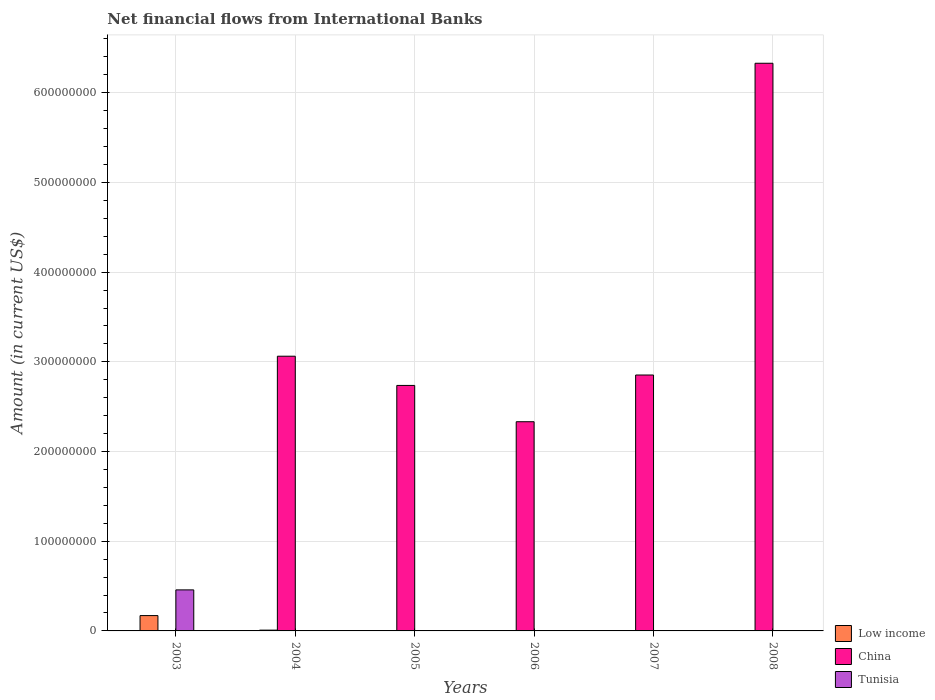How many different coloured bars are there?
Your answer should be very brief. 3. Are the number of bars on each tick of the X-axis equal?
Give a very brief answer. No. What is the net financial aid flows in China in 2006?
Keep it short and to the point. 2.33e+08. Across all years, what is the maximum net financial aid flows in China?
Offer a very short reply. 6.33e+08. In which year was the net financial aid flows in Low income maximum?
Keep it short and to the point. 2003. What is the total net financial aid flows in Low income in the graph?
Your answer should be compact. 1.80e+07. What is the difference between the net financial aid flows in China in 2007 and that in 2008?
Give a very brief answer. -3.48e+08. What is the difference between the net financial aid flows in Low income in 2007 and the net financial aid flows in Tunisia in 2003?
Give a very brief answer. -4.58e+07. What is the average net financial aid flows in Low income per year?
Give a very brief answer. 3.00e+06. In the year 2004, what is the difference between the net financial aid flows in China and net financial aid flows in Low income?
Provide a short and direct response. 3.05e+08. In how many years, is the net financial aid flows in China greater than 520000000 US$?
Keep it short and to the point. 1. What is the ratio of the net financial aid flows in China in 2005 to that in 2006?
Make the answer very short. 1.17. What is the difference between the highest and the second highest net financial aid flows in China?
Provide a short and direct response. 3.27e+08. What is the difference between the highest and the lowest net financial aid flows in Tunisia?
Offer a very short reply. 4.58e+07. Are all the bars in the graph horizontal?
Your response must be concise. No. How many years are there in the graph?
Your answer should be very brief. 6. What is the difference between two consecutive major ticks on the Y-axis?
Your answer should be compact. 1.00e+08. Does the graph contain any zero values?
Your response must be concise. Yes. How many legend labels are there?
Provide a short and direct response. 3. What is the title of the graph?
Your answer should be compact. Net financial flows from International Banks. What is the Amount (in current US$) in Low income in 2003?
Provide a succinct answer. 1.71e+07. What is the Amount (in current US$) of China in 2003?
Your answer should be very brief. 0. What is the Amount (in current US$) in Tunisia in 2003?
Provide a short and direct response. 4.58e+07. What is the Amount (in current US$) of Low income in 2004?
Ensure brevity in your answer.  8.75e+05. What is the Amount (in current US$) of China in 2004?
Keep it short and to the point. 3.06e+08. What is the Amount (in current US$) in Tunisia in 2004?
Ensure brevity in your answer.  0. What is the Amount (in current US$) in Low income in 2005?
Keep it short and to the point. 0. What is the Amount (in current US$) in China in 2005?
Keep it short and to the point. 2.74e+08. What is the Amount (in current US$) in China in 2006?
Ensure brevity in your answer.  2.33e+08. What is the Amount (in current US$) of Tunisia in 2006?
Keep it short and to the point. 0. What is the Amount (in current US$) in Low income in 2007?
Provide a short and direct response. 0. What is the Amount (in current US$) of China in 2007?
Your answer should be very brief. 2.85e+08. What is the Amount (in current US$) of Tunisia in 2007?
Provide a short and direct response. 0. What is the Amount (in current US$) of China in 2008?
Your answer should be very brief. 6.33e+08. Across all years, what is the maximum Amount (in current US$) in Low income?
Your answer should be very brief. 1.71e+07. Across all years, what is the maximum Amount (in current US$) of China?
Your answer should be compact. 6.33e+08. Across all years, what is the maximum Amount (in current US$) in Tunisia?
Ensure brevity in your answer.  4.58e+07. Across all years, what is the minimum Amount (in current US$) in Tunisia?
Make the answer very short. 0. What is the total Amount (in current US$) in Low income in the graph?
Offer a very short reply. 1.80e+07. What is the total Amount (in current US$) of China in the graph?
Ensure brevity in your answer.  1.73e+09. What is the total Amount (in current US$) in Tunisia in the graph?
Make the answer very short. 4.58e+07. What is the difference between the Amount (in current US$) of Low income in 2003 and that in 2004?
Offer a very short reply. 1.62e+07. What is the difference between the Amount (in current US$) of China in 2004 and that in 2005?
Make the answer very short. 3.26e+07. What is the difference between the Amount (in current US$) in China in 2004 and that in 2006?
Your answer should be very brief. 7.30e+07. What is the difference between the Amount (in current US$) of China in 2004 and that in 2007?
Ensure brevity in your answer.  2.10e+07. What is the difference between the Amount (in current US$) in China in 2004 and that in 2008?
Provide a succinct answer. -3.27e+08. What is the difference between the Amount (in current US$) of China in 2005 and that in 2006?
Make the answer very short. 4.05e+07. What is the difference between the Amount (in current US$) of China in 2005 and that in 2007?
Keep it short and to the point. -1.16e+07. What is the difference between the Amount (in current US$) of China in 2005 and that in 2008?
Provide a succinct answer. -3.59e+08. What is the difference between the Amount (in current US$) of China in 2006 and that in 2007?
Offer a very short reply. -5.21e+07. What is the difference between the Amount (in current US$) of China in 2006 and that in 2008?
Offer a terse response. -4.00e+08. What is the difference between the Amount (in current US$) in China in 2007 and that in 2008?
Ensure brevity in your answer.  -3.48e+08. What is the difference between the Amount (in current US$) of Low income in 2003 and the Amount (in current US$) of China in 2004?
Offer a terse response. -2.89e+08. What is the difference between the Amount (in current US$) in Low income in 2003 and the Amount (in current US$) in China in 2005?
Your response must be concise. -2.57e+08. What is the difference between the Amount (in current US$) in Low income in 2003 and the Amount (in current US$) in China in 2006?
Provide a succinct answer. -2.16e+08. What is the difference between the Amount (in current US$) in Low income in 2003 and the Amount (in current US$) in China in 2007?
Provide a succinct answer. -2.68e+08. What is the difference between the Amount (in current US$) in Low income in 2003 and the Amount (in current US$) in China in 2008?
Make the answer very short. -6.16e+08. What is the difference between the Amount (in current US$) of Low income in 2004 and the Amount (in current US$) of China in 2005?
Give a very brief answer. -2.73e+08. What is the difference between the Amount (in current US$) of Low income in 2004 and the Amount (in current US$) of China in 2006?
Your response must be concise. -2.32e+08. What is the difference between the Amount (in current US$) in Low income in 2004 and the Amount (in current US$) in China in 2007?
Your response must be concise. -2.84e+08. What is the difference between the Amount (in current US$) in Low income in 2004 and the Amount (in current US$) in China in 2008?
Provide a short and direct response. -6.32e+08. What is the average Amount (in current US$) in Low income per year?
Offer a terse response. 3.00e+06. What is the average Amount (in current US$) in China per year?
Offer a terse response. 2.89e+08. What is the average Amount (in current US$) of Tunisia per year?
Provide a succinct answer. 7.63e+06. In the year 2003, what is the difference between the Amount (in current US$) of Low income and Amount (in current US$) of Tunisia?
Provide a short and direct response. -2.86e+07. In the year 2004, what is the difference between the Amount (in current US$) in Low income and Amount (in current US$) in China?
Provide a succinct answer. -3.05e+08. What is the ratio of the Amount (in current US$) in Low income in 2003 to that in 2004?
Keep it short and to the point. 19.55. What is the ratio of the Amount (in current US$) of China in 2004 to that in 2005?
Ensure brevity in your answer.  1.12. What is the ratio of the Amount (in current US$) of China in 2004 to that in 2006?
Keep it short and to the point. 1.31. What is the ratio of the Amount (in current US$) of China in 2004 to that in 2007?
Keep it short and to the point. 1.07. What is the ratio of the Amount (in current US$) in China in 2004 to that in 2008?
Ensure brevity in your answer.  0.48. What is the ratio of the Amount (in current US$) of China in 2005 to that in 2006?
Ensure brevity in your answer.  1.17. What is the ratio of the Amount (in current US$) of China in 2005 to that in 2007?
Your answer should be very brief. 0.96. What is the ratio of the Amount (in current US$) of China in 2005 to that in 2008?
Make the answer very short. 0.43. What is the ratio of the Amount (in current US$) in China in 2006 to that in 2007?
Ensure brevity in your answer.  0.82. What is the ratio of the Amount (in current US$) in China in 2006 to that in 2008?
Keep it short and to the point. 0.37. What is the ratio of the Amount (in current US$) of China in 2007 to that in 2008?
Provide a succinct answer. 0.45. What is the difference between the highest and the second highest Amount (in current US$) in China?
Offer a terse response. 3.27e+08. What is the difference between the highest and the lowest Amount (in current US$) in Low income?
Keep it short and to the point. 1.71e+07. What is the difference between the highest and the lowest Amount (in current US$) in China?
Provide a succinct answer. 6.33e+08. What is the difference between the highest and the lowest Amount (in current US$) of Tunisia?
Offer a terse response. 4.58e+07. 